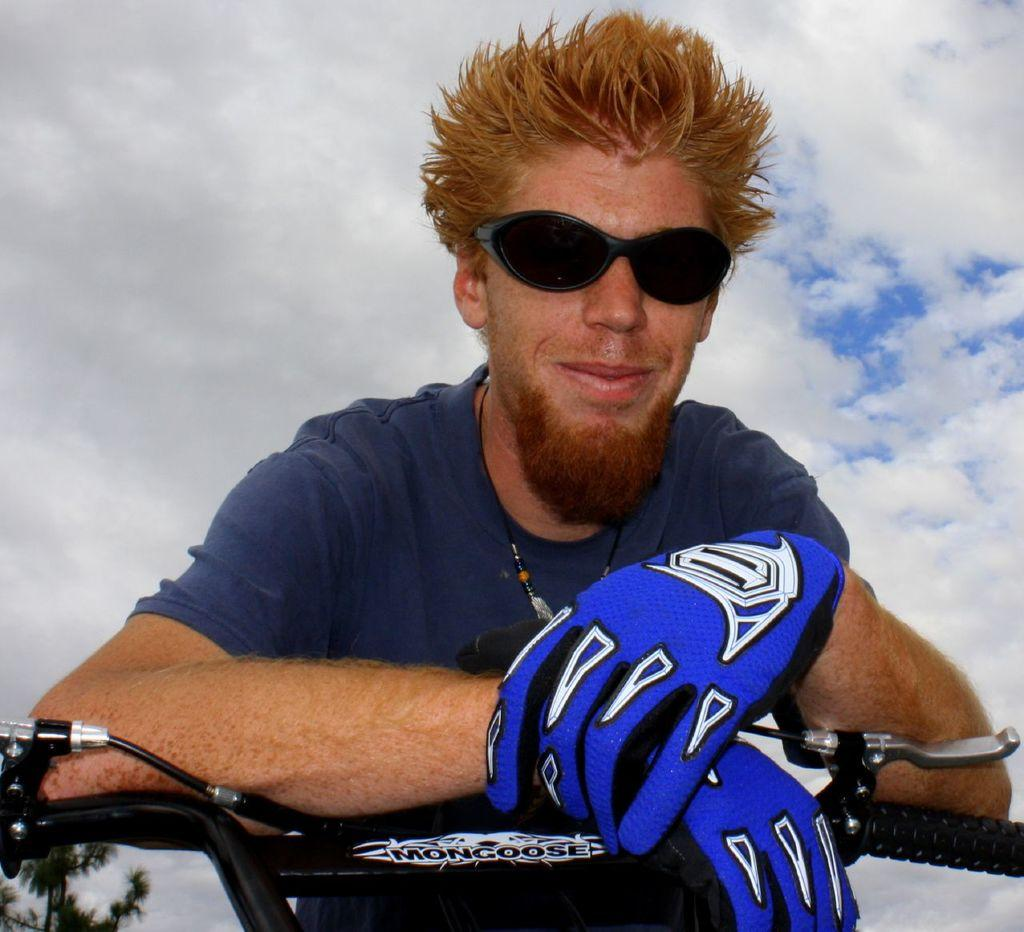Where was the image taken? The image is taken outdoors. Who is present in the image? There is a man in the image. What is the man doing in the image? The man is placing his hands on a bike. What is the man wearing on his hands? The man is wearing gloves on his hands. What can be seen in the background of the image? There is a sky with clouds and trees in the background of the image. Is there a bear exchanging camping gear with the man in the image? No, there is no bear or camping gear exchange present in the image. 